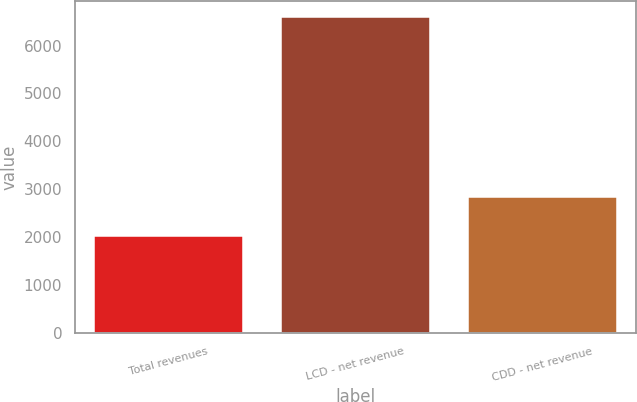Convert chart to OTSL. <chart><loc_0><loc_0><loc_500><loc_500><bar_chart><fcel>Total revenues<fcel>LCD - net revenue<fcel>CDD - net revenue<nl><fcel>2016<fcel>6593.9<fcel>2844.1<nl></chart> 